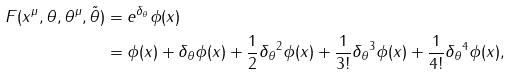Convert formula to latex. <formula><loc_0><loc_0><loc_500><loc_500>F ( x ^ { \mu } , \theta , \theta ^ { \mu } , \tilde { \theta } ) & = e ^ { \delta _ { \theta } } \phi ( x ) \\ & = \phi ( x ) + \delta _ { \theta } \phi ( x ) + \frac { 1 } { 2 } \delta _ { \theta } { ^ { 2 } } \phi ( x ) + \frac { 1 } { 3 ! } \delta _ { \theta } { ^ { 3 } } \phi ( x ) + \frac { 1 } { 4 ! } \delta _ { \theta } { ^ { 4 } } \phi ( x ) ,</formula> 